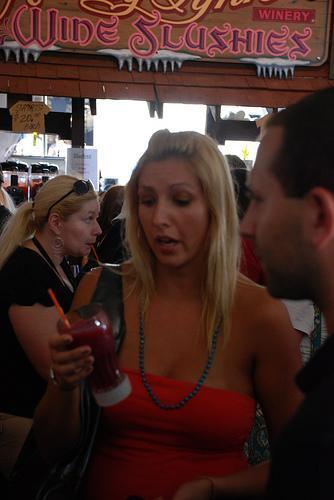How many straws are visible?
Give a very brief answer. 2. 